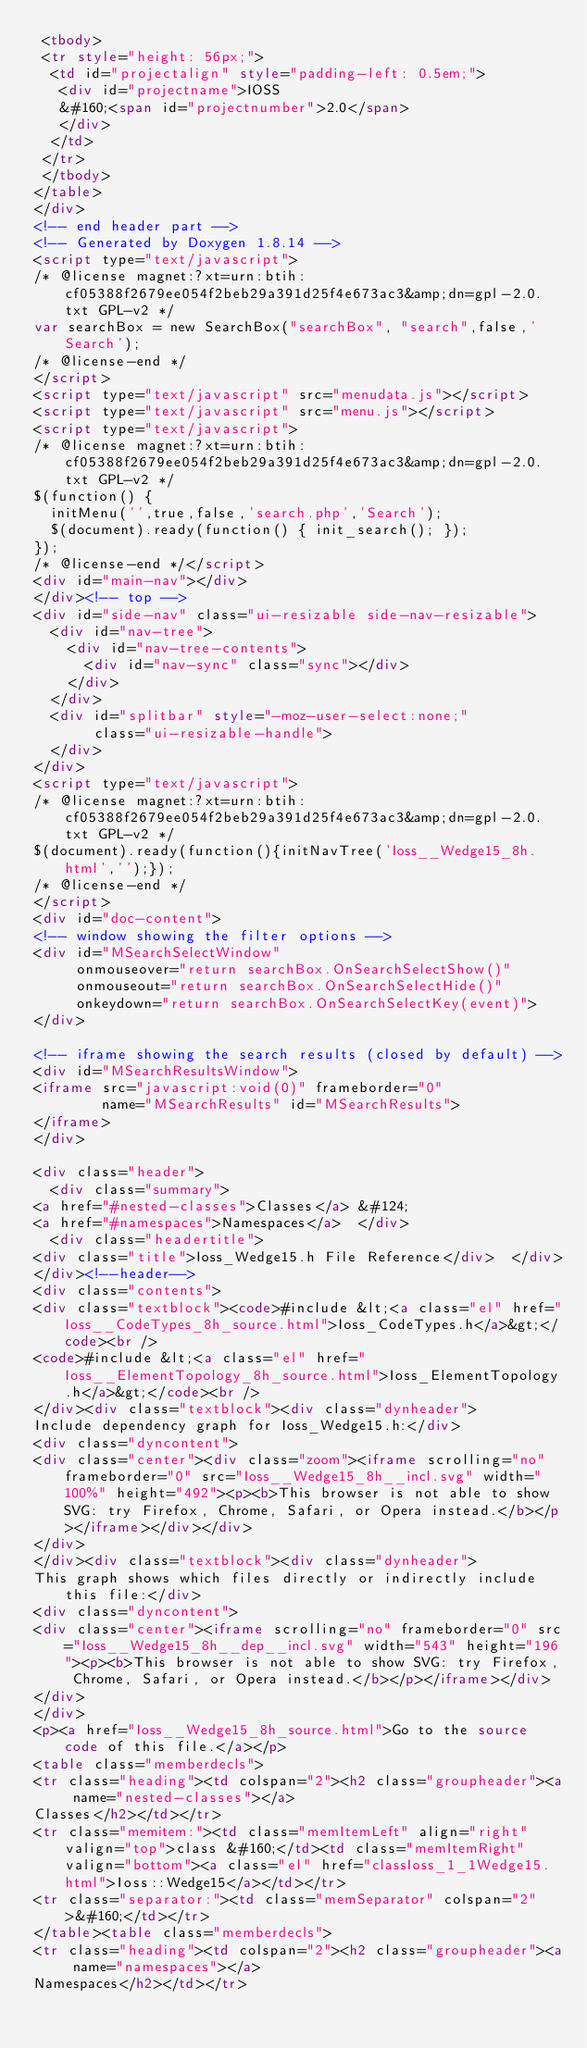Convert code to text. <code><loc_0><loc_0><loc_500><loc_500><_HTML_> <tbody>
 <tr style="height: 56px;">
  <td id="projectalign" style="padding-left: 0.5em;">
   <div id="projectname">IOSS
   &#160;<span id="projectnumber">2.0</span>
   </div>
  </td>
 </tr>
 </tbody>
</table>
</div>
<!-- end header part -->
<!-- Generated by Doxygen 1.8.14 -->
<script type="text/javascript">
/* @license magnet:?xt=urn:btih:cf05388f2679ee054f2beb29a391d25f4e673ac3&amp;dn=gpl-2.0.txt GPL-v2 */
var searchBox = new SearchBox("searchBox", "search",false,'Search');
/* @license-end */
</script>
<script type="text/javascript" src="menudata.js"></script>
<script type="text/javascript" src="menu.js"></script>
<script type="text/javascript">
/* @license magnet:?xt=urn:btih:cf05388f2679ee054f2beb29a391d25f4e673ac3&amp;dn=gpl-2.0.txt GPL-v2 */
$(function() {
  initMenu('',true,false,'search.php','Search');
  $(document).ready(function() { init_search(); });
});
/* @license-end */</script>
<div id="main-nav"></div>
</div><!-- top -->
<div id="side-nav" class="ui-resizable side-nav-resizable">
  <div id="nav-tree">
    <div id="nav-tree-contents">
      <div id="nav-sync" class="sync"></div>
    </div>
  </div>
  <div id="splitbar" style="-moz-user-select:none;" 
       class="ui-resizable-handle">
  </div>
</div>
<script type="text/javascript">
/* @license magnet:?xt=urn:btih:cf05388f2679ee054f2beb29a391d25f4e673ac3&amp;dn=gpl-2.0.txt GPL-v2 */
$(document).ready(function(){initNavTree('Ioss__Wedge15_8h.html','');});
/* @license-end */
</script>
<div id="doc-content">
<!-- window showing the filter options -->
<div id="MSearchSelectWindow"
     onmouseover="return searchBox.OnSearchSelectShow()"
     onmouseout="return searchBox.OnSearchSelectHide()"
     onkeydown="return searchBox.OnSearchSelectKey(event)">
</div>

<!-- iframe showing the search results (closed by default) -->
<div id="MSearchResultsWindow">
<iframe src="javascript:void(0)" frameborder="0" 
        name="MSearchResults" id="MSearchResults">
</iframe>
</div>

<div class="header">
  <div class="summary">
<a href="#nested-classes">Classes</a> &#124;
<a href="#namespaces">Namespaces</a>  </div>
  <div class="headertitle">
<div class="title">Ioss_Wedge15.h File Reference</div>  </div>
</div><!--header-->
<div class="contents">
<div class="textblock"><code>#include &lt;<a class="el" href="Ioss__CodeTypes_8h_source.html">Ioss_CodeTypes.h</a>&gt;</code><br />
<code>#include &lt;<a class="el" href="Ioss__ElementTopology_8h_source.html">Ioss_ElementTopology.h</a>&gt;</code><br />
</div><div class="textblock"><div class="dynheader">
Include dependency graph for Ioss_Wedge15.h:</div>
<div class="dyncontent">
<div class="center"><div class="zoom"><iframe scrolling="no" frameborder="0" src="Ioss__Wedge15_8h__incl.svg" width="100%" height="492"><p><b>This browser is not able to show SVG: try Firefox, Chrome, Safari, or Opera instead.</b></p></iframe></div></div>
</div>
</div><div class="textblock"><div class="dynheader">
This graph shows which files directly or indirectly include this file:</div>
<div class="dyncontent">
<div class="center"><iframe scrolling="no" frameborder="0" src="Ioss__Wedge15_8h__dep__incl.svg" width="543" height="196"><p><b>This browser is not able to show SVG: try Firefox, Chrome, Safari, or Opera instead.</b></p></iframe></div>
</div>
</div>
<p><a href="Ioss__Wedge15_8h_source.html">Go to the source code of this file.</a></p>
<table class="memberdecls">
<tr class="heading"><td colspan="2"><h2 class="groupheader"><a name="nested-classes"></a>
Classes</h2></td></tr>
<tr class="memitem:"><td class="memItemLeft" align="right" valign="top">class &#160;</td><td class="memItemRight" valign="bottom"><a class="el" href="classIoss_1_1Wedge15.html">Ioss::Wedge15</a></td></tr>
<tr class="separator:"><td class="memSeparator" colspan="2">&#160;</td></tr>
</table><table class="memberdecls">
<tr class="heading"><td colspan="2"><h2 class="groupheader"><a name="namespaces"></a>
Namespaces</h2></td></tr></code> 